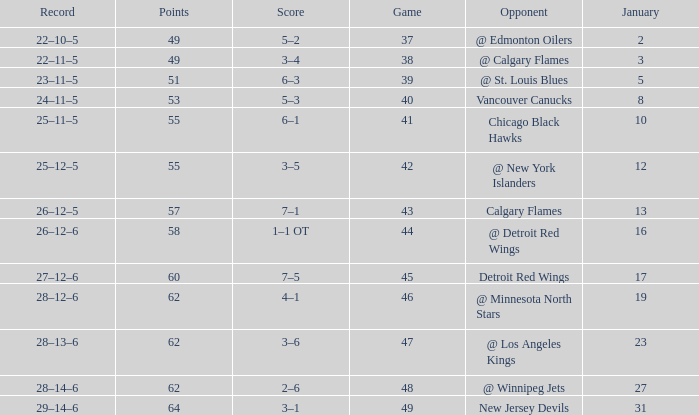How many Games have a Score of 2–6, and Points larger than 62? 0.0. 